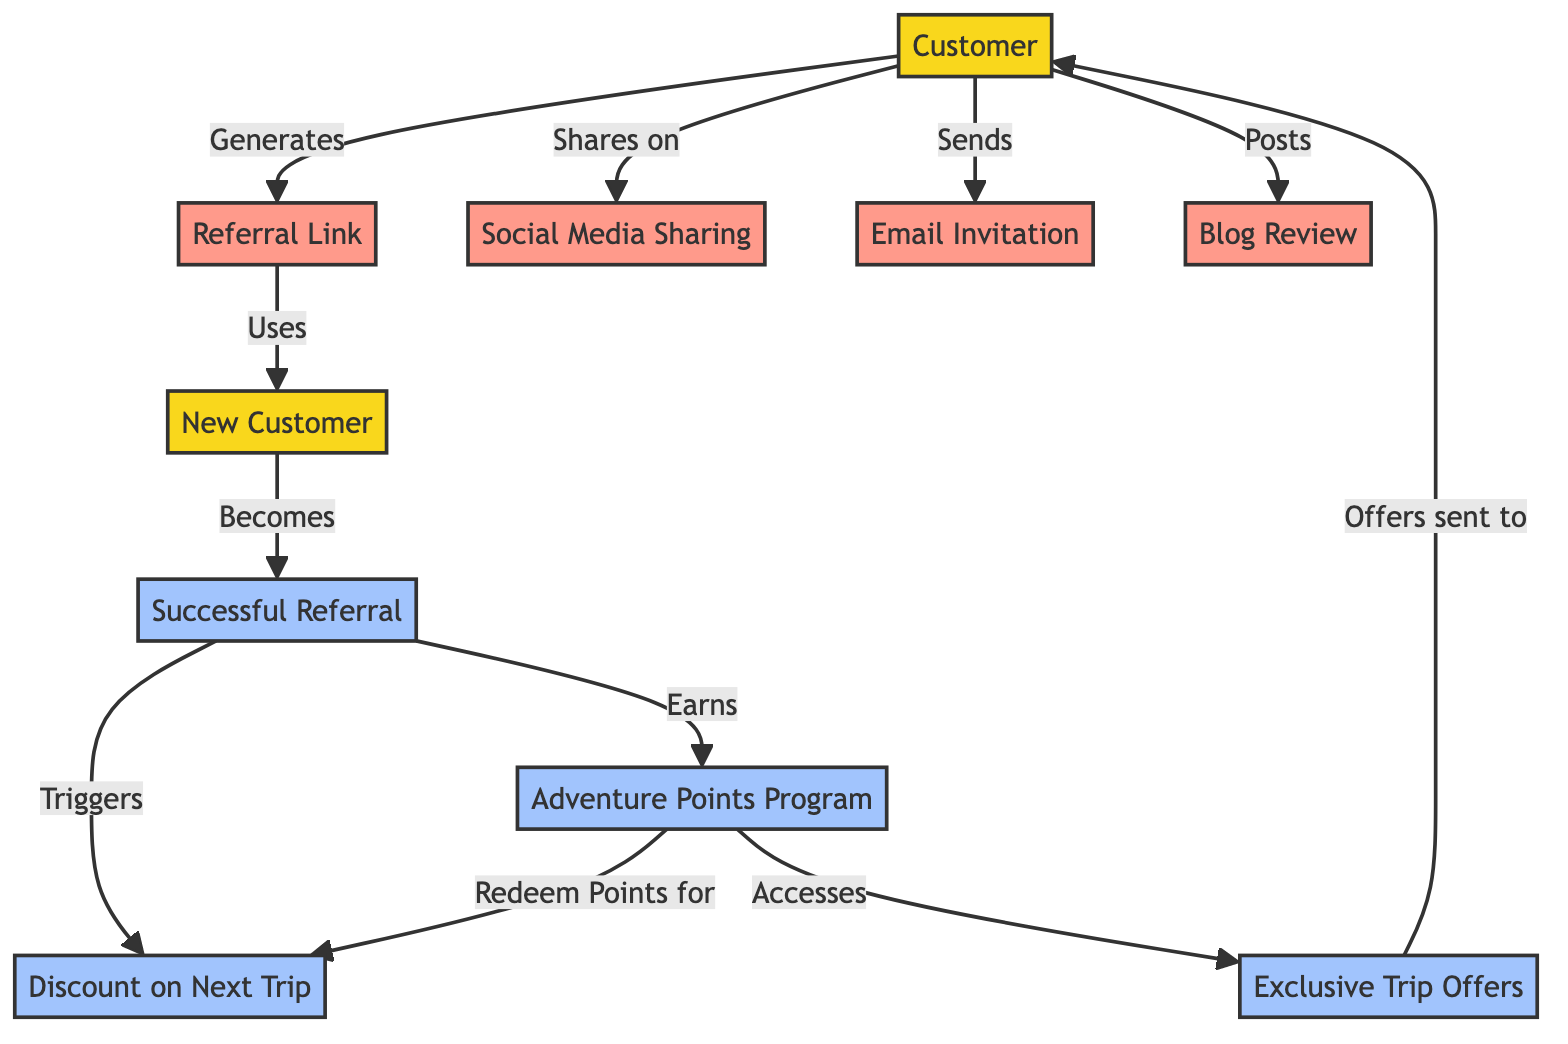What's the total number of nodes in the diagram? The diagram contains 10 nodes which represent different concepts or actions related to the referral program structure.
Answer: 10 What relationship does the "Customer" have with the "Referral Link"? The "Customer" generates the "Referral Link," indicating an action initiated by the customer.
Answer: Generates What does "New Customer" become after the referral process? The "New Customer" transitions to become a "Successful Referral" as indicated by the arrow connecting them, showing the outcome of the referral process.
Answer: Successful Referral How many actions can a customer take to share the referral? The customer can take three actions: sharing on social media, sending an email invitation, and posting a blog review. Each action is represented as a distinct edge originating from the "Customer" node.
Answer: 3 What does the "Successful Referral" earn? The "Successful Referral" earns "Adventure Points Program," which allows them to participate in the rewards program after completing a referral successfully.
Answer: Adventure Points Program What does the "Adventure Points Program" allow a customer to redeem? The "Adventure Points Program" allows a customer to redeem points for a "Discount on Next Trip" as indicated by the relationship flow in the diagram.
Answer: Discount on Next Trip Which action follows the "Successful Referral"? Following "Successful Referral," the next action is the triggering of a "Discount on Next Trip," demonstrating a reward for the successful referral.
Answer: Triggers What type of offers does the "Exclusive Trip Offers" provide to the customer? The "Exclusive Trip Offers" sends offers to the "Customer," indicating that these exclusive deals are available to the referred customer.
Answer: Offers sent to What is required for a referral to become successful? For a referral to become successful, a "New Customer" must use the "Referral Link." This indicates the need for the new individual to engage with the referral process properly.
Answer: Uses 